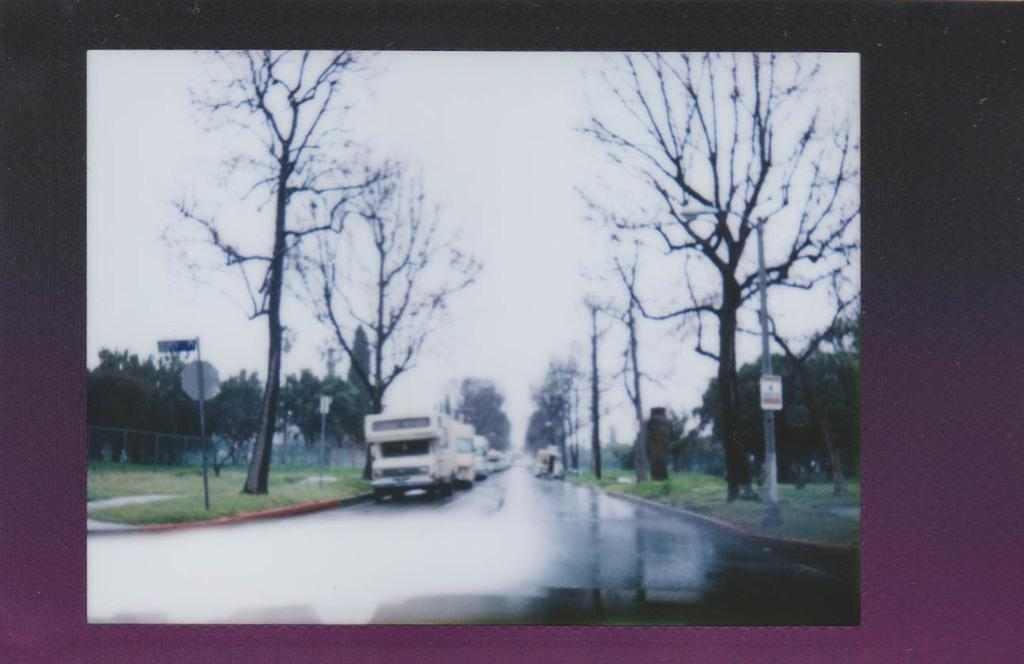What type of natural elements can be seen in the image? There are trees in the image. What type of man-made elements can be seen in the image? There are vehicles on the road in the image. What part of the natural environment is visible in the image? The sky is visible in the image. How many babies are sitting on the arch in the image? There is no arch or babies present in the image. 